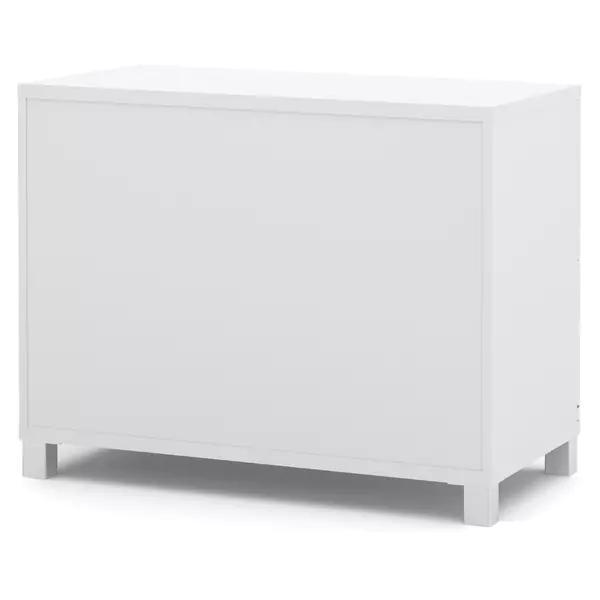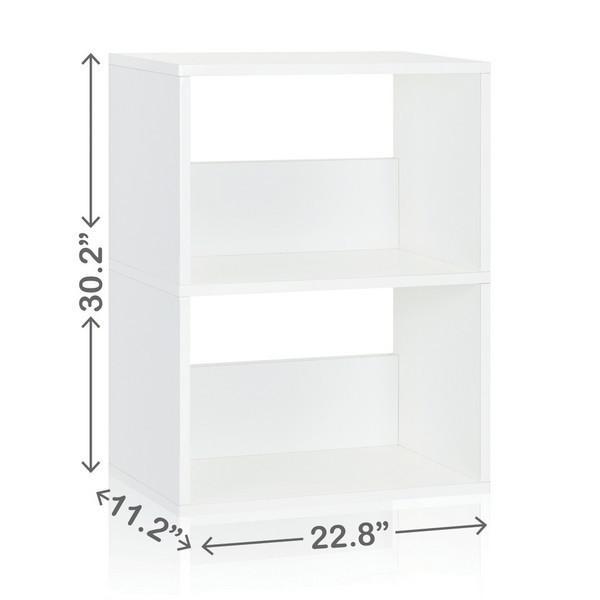The first image is the image on the left, the second image is the image on the right. Analyze the images presented: Is the assertion "There is a curtain near a bookcase in at least one of the images." valid? Answer yes or no. No. The first image is the image on the left, the second image is the image on the right. Considering the images on both sides, is "Each image shows one rectangular storage unit, with no other furniture and no storage contents." valid? Answer yes or no. Yes. 